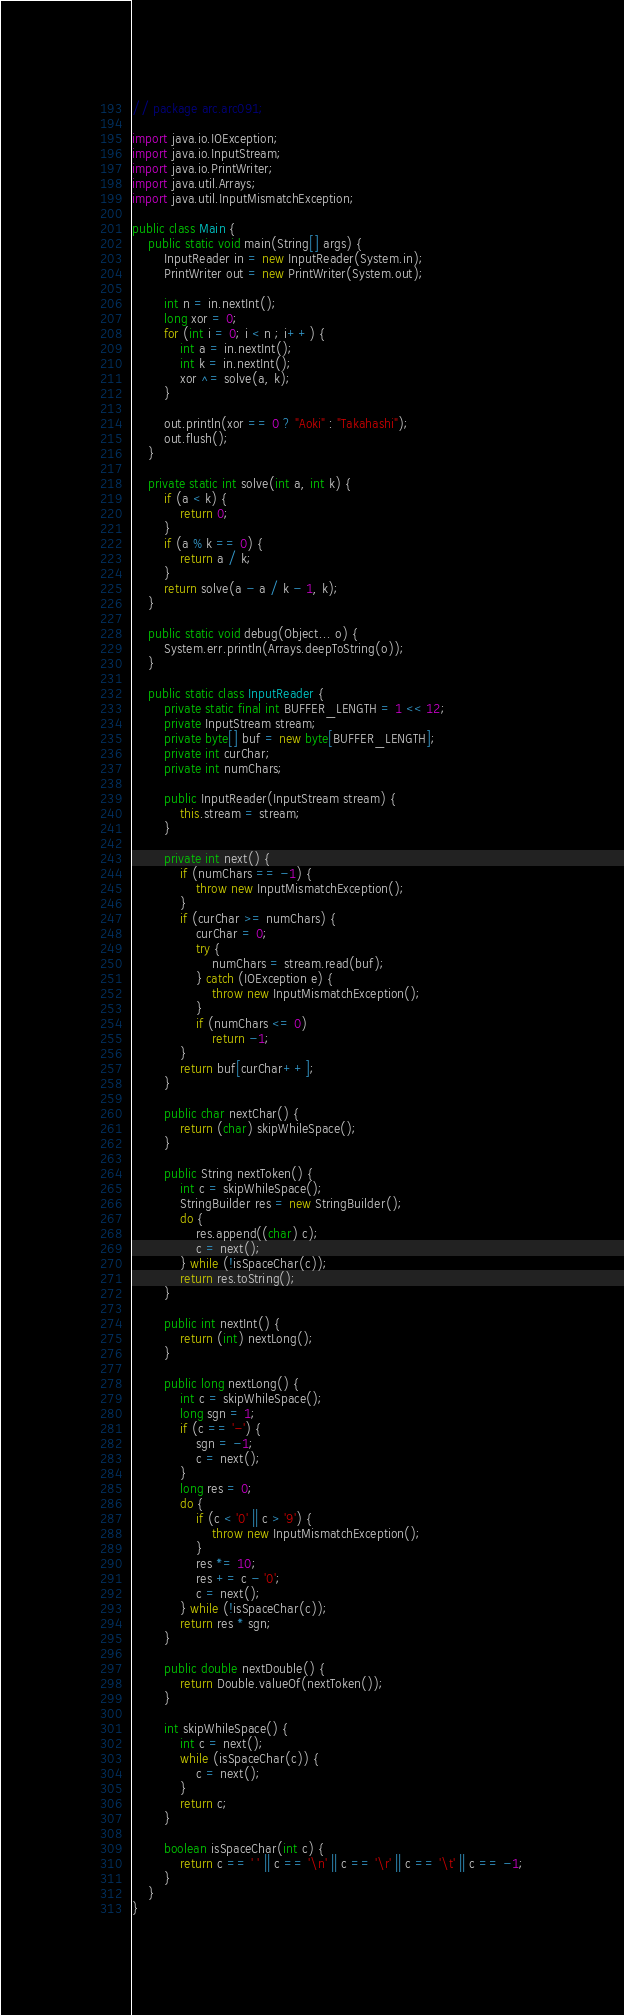Convert code to text. <code><loc_0><loc_0><loc_500><loc_500><_Java_>// package arc.arc091;

import java.io.IOException;
import java.io.InputStream;
import java.io.PrintWriter;
import java.util.Arrays;
import java.util.InputMismatchException;

public class Main {
    public static void main(String[] args) {
        InputReader in = new InputReader(System.in);
        PrintWriter out = new PrintWriter(System.out);

        int n = in.nextInt();
        long xor = 0;
        for (int i = 0; i < n ; i++) {
            int a = in.nextInt();
            int k = in.nextInt();
            xor ^= solve(a, k);
        }

        out.println(xor == 0 ? "Aoki" : "Takahashi");
        out.flush();
    }

    private static int solve(int a, int k) {
        if (a < k) {
            return 0;
        }
        if (a % k == 0) {
            return a / k;
        }
        return solve(a - a / k - 1, k);
    }

    public static void debug(Object... o) {
        System.err.println(Arrays.deepToString(o));
    }

    public static class InputReader {
        private static final int BUFFER_LENGTH = 1 << 12;
        private InputStream stream;
        private byte[] buf = new byte[BUFFER_LENGTH];
        private int curChar;
        private int numChars;

        public InputReader(InputStream stream) {
            this.stream = stream;
        }

        private int next() {
            if (numChars == -1) {
                throw new InputMismatchException();
            }
            if (curChar >= numChars) {
                curChar = 0;
                try {
                    numChars = stream.read(buf);
                } catch (IOException e) {
                    throw new InputMismatchException();
                }
                if (numChars <= 0)
                    return -1;
            }
            return buf[curChar++];
        }

        public char nextChar() {
            return (char) skipWhileSpace();
        }

        public String nextToken() {
            int c = skipWhileSpace();
            StringBuilder res = new StringBuilder();
            do {
                res.append((char) c);
                c = next();
            } while (!isSpaceChar(c));
            return res.toString();
        }

        public int nextInt() {
            return (int) nextLong();
        }

        public long nextLong() {
            int c = skipWhileSpace();
            long sgn = 1;
            if (c == '-') {
                sgn = -1;
                c = next();
            }
            long res = 0;
            do {
                if (c < '0' || c > '9') {
                    throw new InputMismatchException();
                }
                res *= 10;
                res += c - '0';
                c = next();
            } while (!isSpaceChar(c));
            return res * sgn;
        }

        public double nextDouble() {
            return Double.valueOf(nextToken());
        }

        int skipWhileSpace() {
            int c = next();
            while (isSpaceChar(c)) {
                c = next();
            }
            return c;
        }

        boolean isSpaceChar(int c) {
            return c == ' ' || c == '\n' || c == '\r' || c == '\t' || c == -1;
        }
    }
}</code> 